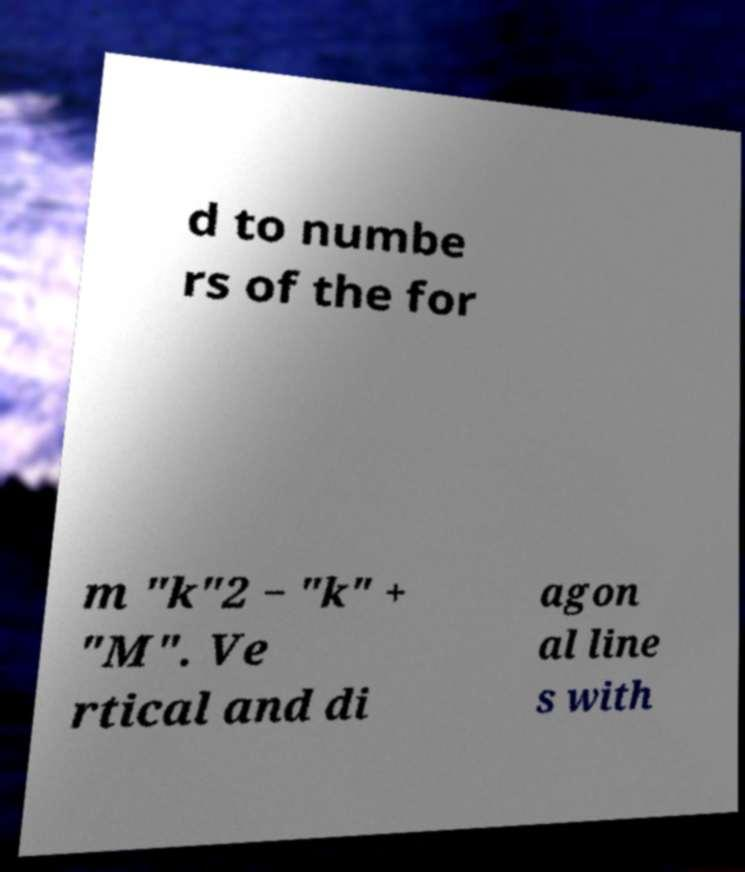There's text embedded in this image that I need extracted. Can you transcribe it verbatim? d to numbe rs of the for m "k"2 − "k" + "M". Ve rtical and di agon al line s with 